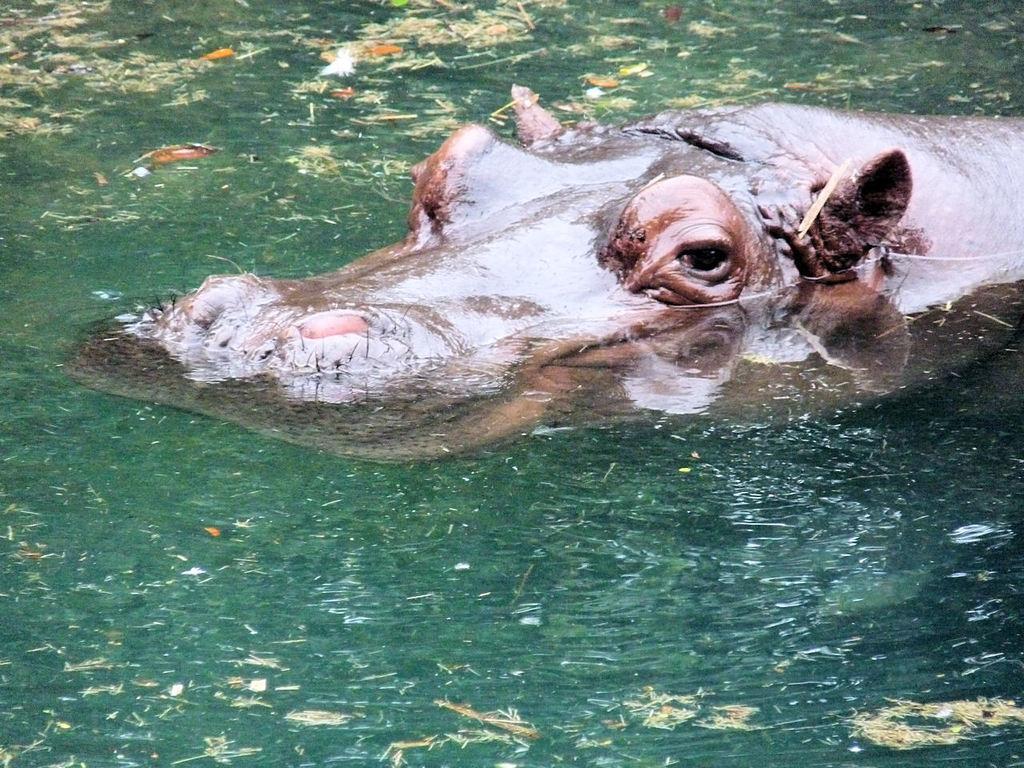In one or two sentences, can you explain what this image depicts? In this image I can see an animal which is brown in color is in the water which are green in color and I can see some grass and few leaves on the surface of the water. 